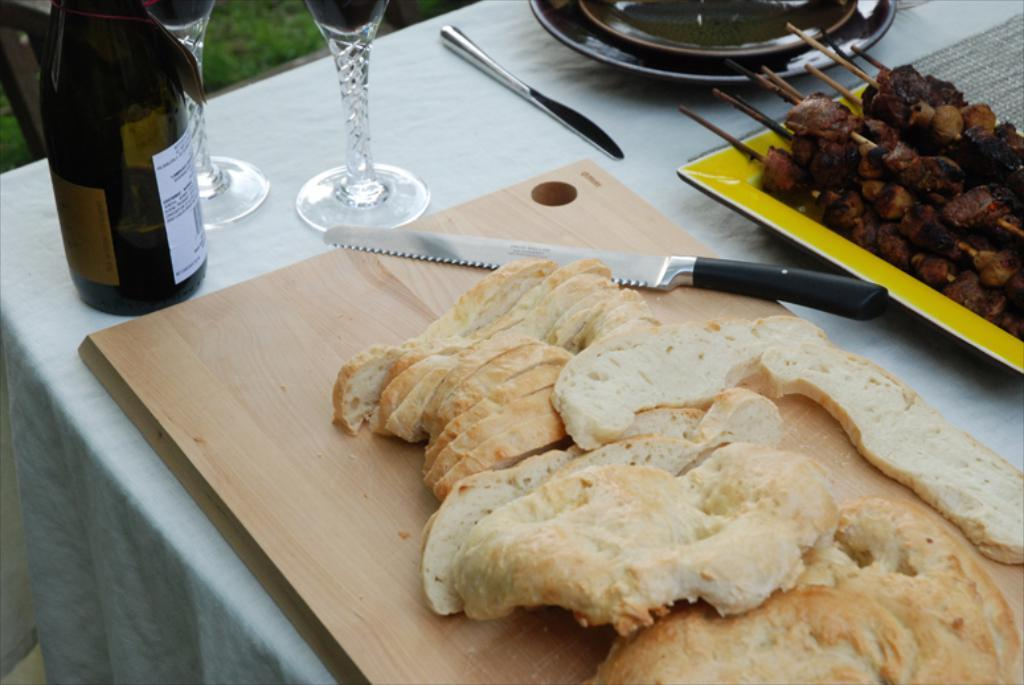What piece of furniture is present in the image? There is a table in the image. What items can be seen on the table? On the table, there is a knife, a glass, a bottle, bread, a tray, and a cloth. Are there any food items on the table? Yes, there are food items on the table. What is visible at the bottom of the image? There is grass at the bottom of the image. What type of trousers can be seen hanging on the table in the image? There are no trousers present on the table in the image. What kind of truck is visible in the background of the image? There is no truck visible in the image; it only features a table with various items and grass at the bottom. 